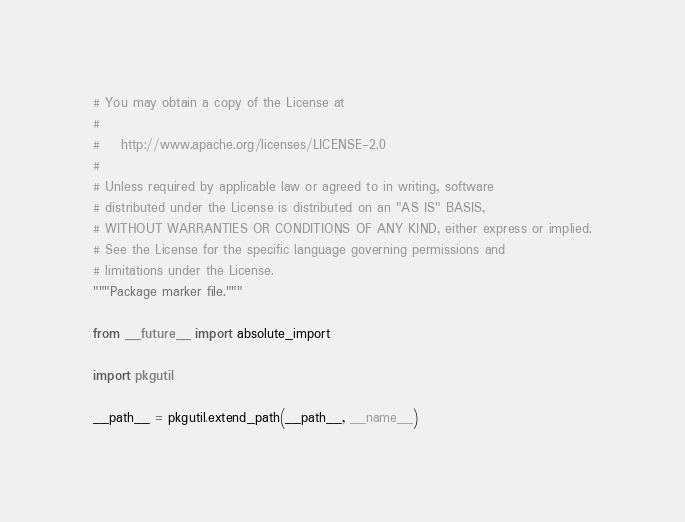Convert code to text. <code><loc_0><loc_0><loc_500><loc_500><_Python_># You may obtain a copy of the License at
#
#    http://www.apache.org/licenses/LICENSE-2.0
#
# Unless required by applicable law or agreed to in writing, software
# distributed under the License is distributed on an "AS IS" BASIS,
# WITHOUT WARRANTIES OR CONDITIONS OF ANY KIND, either express or implied.
# See the License for the specific language governing permissions and
# limitations under the License.
"""Package marker file."""

from __future__ import absolute_import

import pkgutil

__path__ = pkgutil.extend_path(__path__, __name__)
</code> 